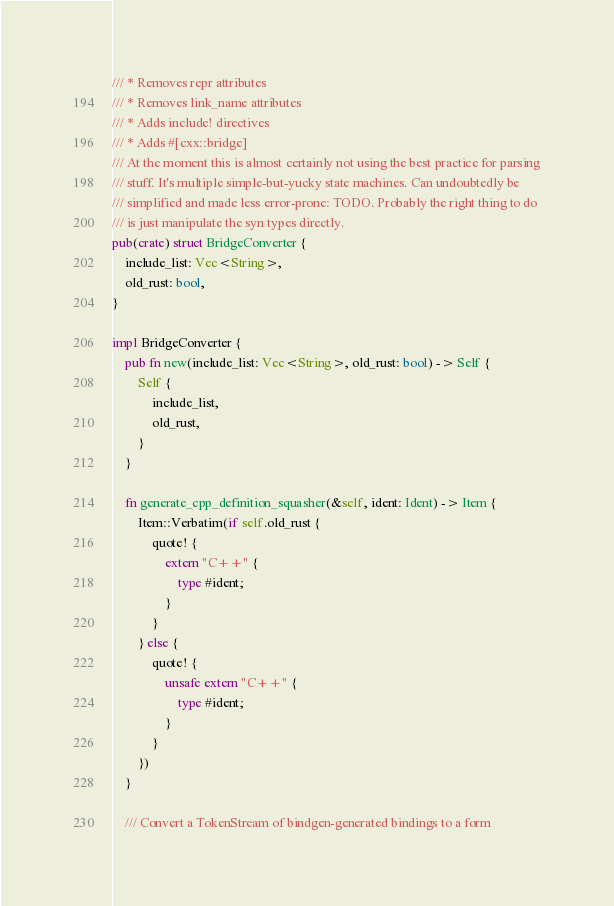<code> <loc_0><loc_0><loc_500><loc_500><_Rust_>/// * Removes repr attributes
/// * Removes link_name attributes
/// * Adds include! directives
/// * Adds #[cxx::bridge]
/// At the moment this is almost certainly not using the best practice for parsing
/// stuff. It's multiple simple-but-yucky state machines. Can undoubtedly be
/// simplified and made less error-prone: TODO. Probably the right thing to do
/// is just manipulate the syn types directly.
pub(crate) struct BridgeConverter {
    include_list: Vec<String>,
    old_rust: bool,
}

impl BridgeConverter {
    pub fn new(include_list: Vec<String>, old_rust: bool) -> Self {
        Self {
            include_list,
            old_rust,
        }
    }

    fn generate_cpp_definition_squasher(&self, ident: Ident) -> Item {
        Item::Verbatim(if self.old_rust {
            quote! {
                extern "C++" {
                    type #ident;
                }
            }
        } else {
            quote! {
                unsafe extern "C++" {
                    type #ident;
                }
            }
        })
    }

    /// Convert a TokenStream of bindgen-generated bindings to a form</code> 